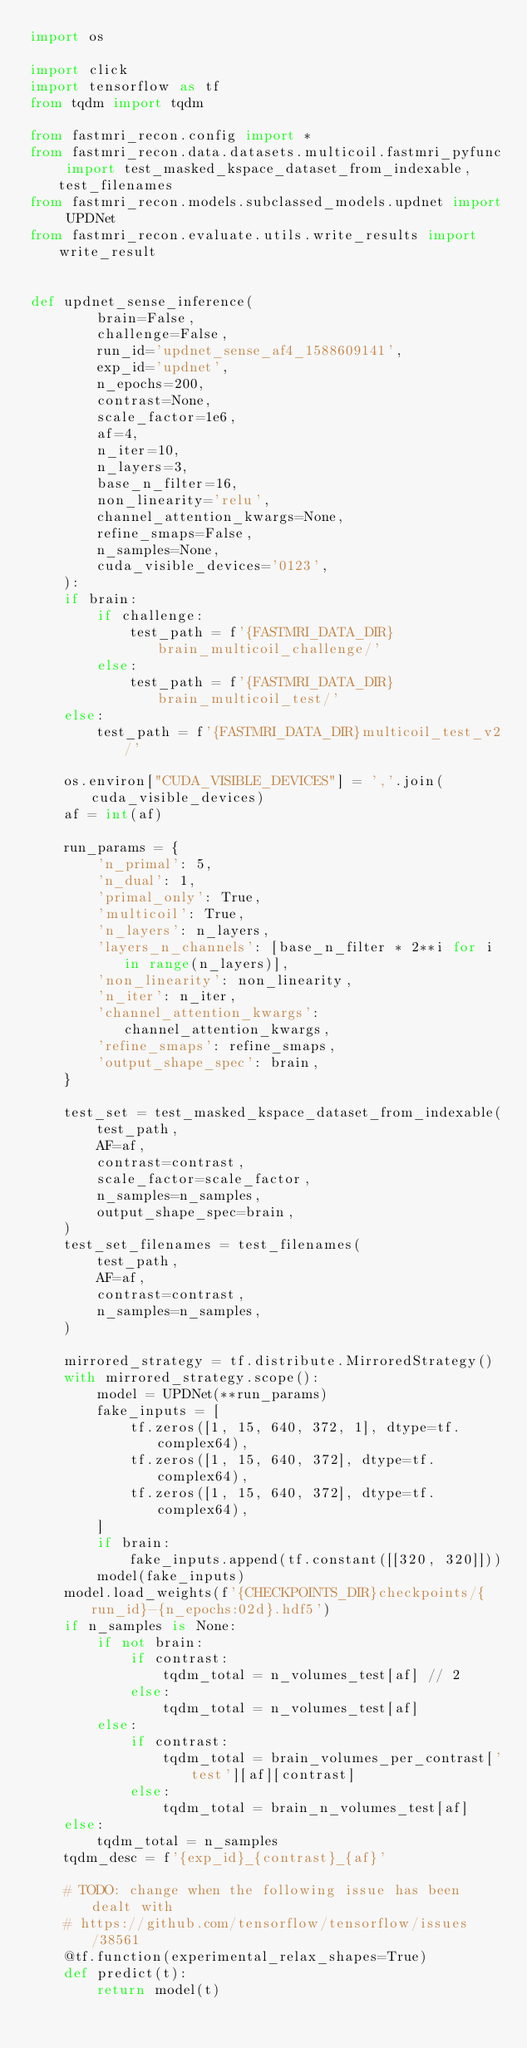<code> <loc_0><loc_0><loc_500><loc_500><_Python_>import os

import click
import tensorflow as tf
from tqdm import tqdm

from fastmri_recon.config import *
from fastmri_recon.data.datasets.multicoil.fastmri_pyfunc import test_masked_kspace_dataset_from_indexable, test_filenames
from fastmri_recon.models.subclassed_models.updnet import UPDNet
from fastmri_recon.evaluate.utils.write_results import write_result


def updnet_sense_inference(
        brain=False,
        challenge=False,
        run_id='updnet_sense_af4_1588609141',
        exp_id='updnet',
        n_epochs=200,
        contrast=None,
        scale_factor=1e6,
        af=4,
        n_iter=10,
        n_layers=3,
        base_n_filter=16,
        non_linearity='relu',
        channel_attention_kwargs=None,
        refine_smaps=False,
        n_samples=None,
        cuda_visible_devices='0123',
    ):
    if brain:
        if challenge:
            test_path = f'{FASTMRI_DATA_DIR}brain_multicoil_challenge/'
        else:
            test_path = f'{FASTMRI_DATA_DIR}brain_multicoil_test/'
    else:
        test_path = f'{FASTMRI_DATA_DIR}multicoil_test_v2/'

    os.environ["CUDA_VISIBLE_DEVICES"] = ','.join(cuda_visible_devices)
    af = int(af)

    run_params = {
        'n_primal': 5,
        'n_dual': 1,
        'primal_only': True,
        'multicoil': True,
        'n_layers': n_layers,
        'layers_n_channels': [base_n_filter * 2**i for i in range(n_layers)],
        'non_linearity': non_linearity,
        'n_iter': n_iter,
        'channel_attention_kwargs': channel_attention_kwargs,
        'refine_smaps': refine_smaps,
        'output_shape_spec': brain,
    }

    test_set = test_masked_kspace_dataset_from_indexable(
        test_path,
        AF=af,
        contrast=contrast,
        scale_factor=scale_factor,
        n_samples=n_samples,
        output_shape_spec=brain,
    )
    test_set_filenames = test_filenames(
        test_path,
        AF=af,
        contrast=contrast,
        n_samples=n_samples,
    )

    mirrored_strategy = tf.distribute.MirroredStrategy()
    with mirrored_strategy.scope():
        model = UPDNet(**run_params)
        fake_inputs = [
            tf.zeros([1, 15, 640, 372, 1], dtype=tf.complex64),
            tf.zeros([1, 15, 640, 372], dtype=tf.complex64),
            tf.zeros([1, 15, 640, 372], dtype=tf.complex64),
        ]
        if brain:
            fake_inputs.append(tf.constant([[320, 320]]))
        model(fake_inputs)
    model.load_weights(f'{CHECKPOINTS_DIR}checkpoints/{run_id}-{n_epochs:02d}.hdf5')
    if n_samples is None:
        if not brain:
            if contrast:
                tqdm_total = n_volumes_test[af] // 2
            else:
                tqdm_total = n_volumes_test[af]
        else:
            if contrast:
                tqdm_total = brain_volumes_per_contrast['test'][af][contrast]
            else:
                tqdm_total = brain_n_volumes_test[af]
    else:
        tqdm_total = n_samples
    tqdm_desc = f'{exp_id}_{contrast}_{af}'

    # TODO: change when the following issue has been dealt with
    # https://github.com/tensorflow/tensorflow/issues/38561
    @tf.function(experimental_relax_shapes=True)
    def predict(t):
        return model(t)
</code> 